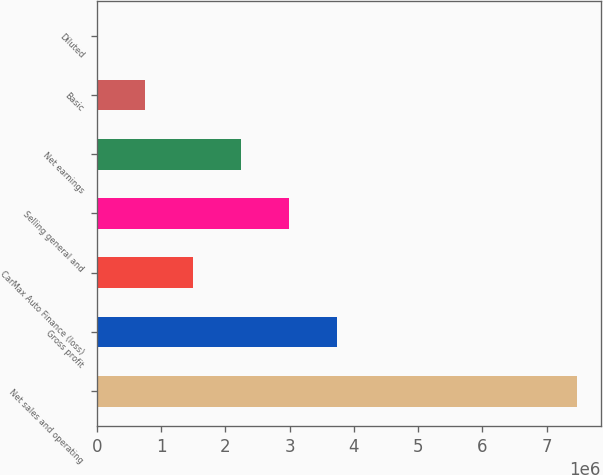Convert chart to OTSL. <chart><loc_0><loc_0><loc_500><loc_500><bar_chart><fcel>Net sales and operating<fcel>Gross profit<fcel>CarMax Auto Finance (loss)<fcel>Selling general and<fcel>Net earnings<fcel>Basic<fcel>Diluted<nl><fcel>7.47019e+06<fcel>3.7351e+06<fcel>1.49404e+06<fcel>2.98808e+06<fcel>2.24106e+06<fcel>747020<fcel>1.26<nl></chart> 